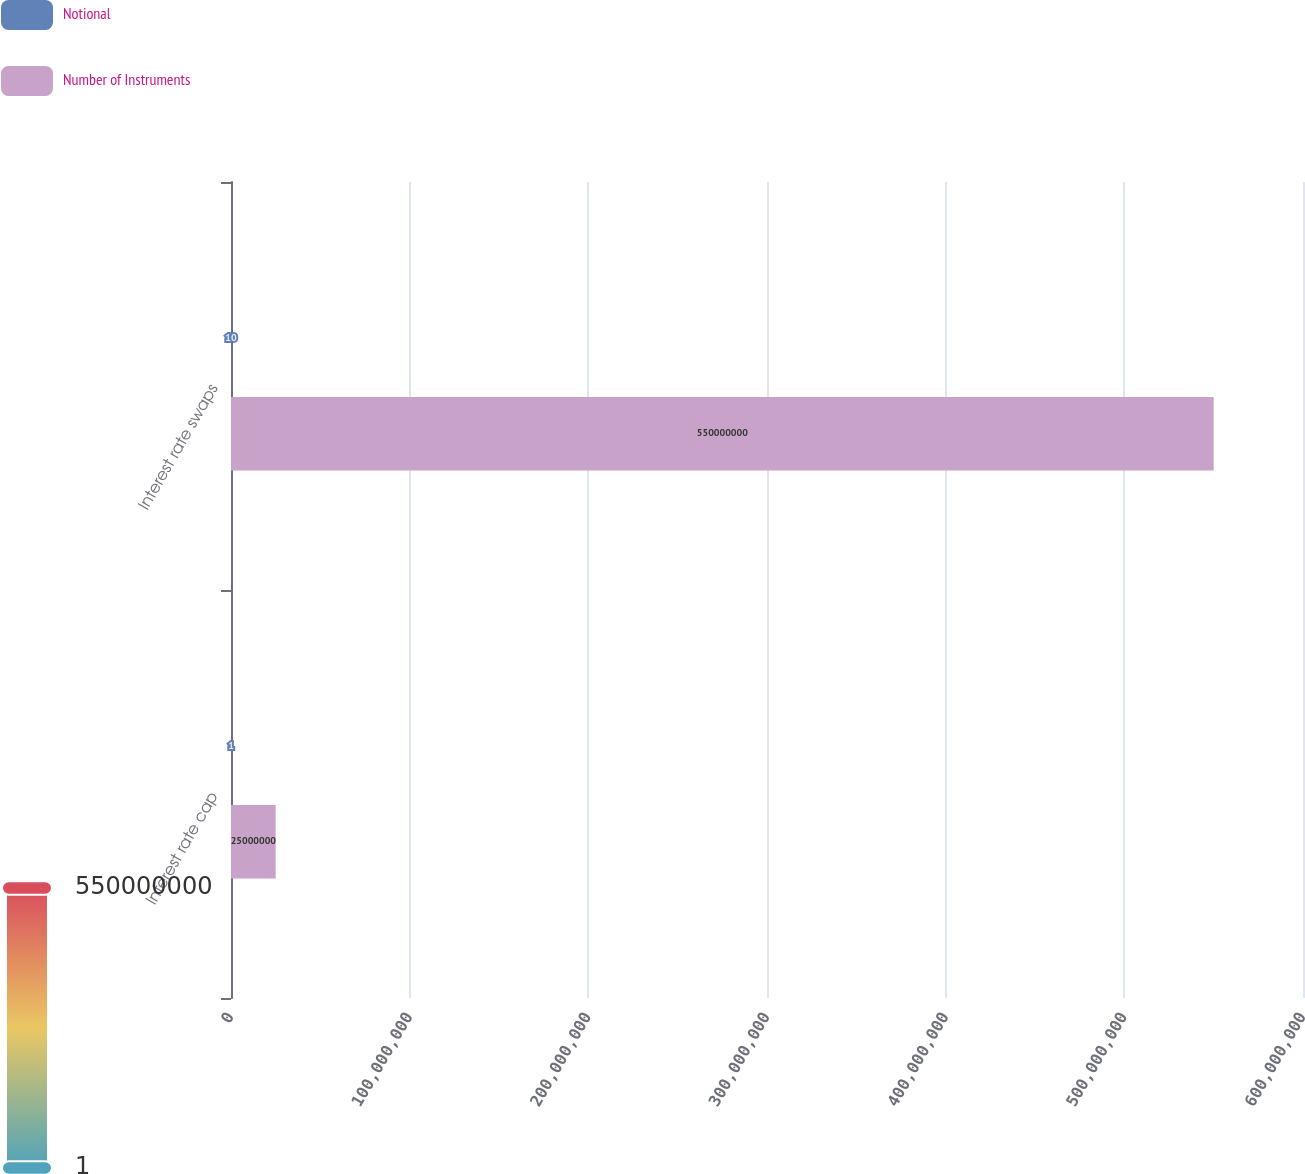Convert chart. <chart><loc_0><loc_0><loc_500><loc_500><stacked_bar_chart><ecel><fcel>Interest rate cap<fcel>Interest rate swaps<nl><fcel>Notional<fcel>1<fcel>10<nl><fcel>Number of Instruments<fcel>2.5e+07<fcel>5.5e+08<nl></chart> 